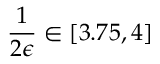Convert formula to latex. <formula><loc_0><loc_0><loc_500><loc_500>\frac { 1 } { 2 \epsilon } \in [ 3 . 7 5 , 4 ]</formula> 